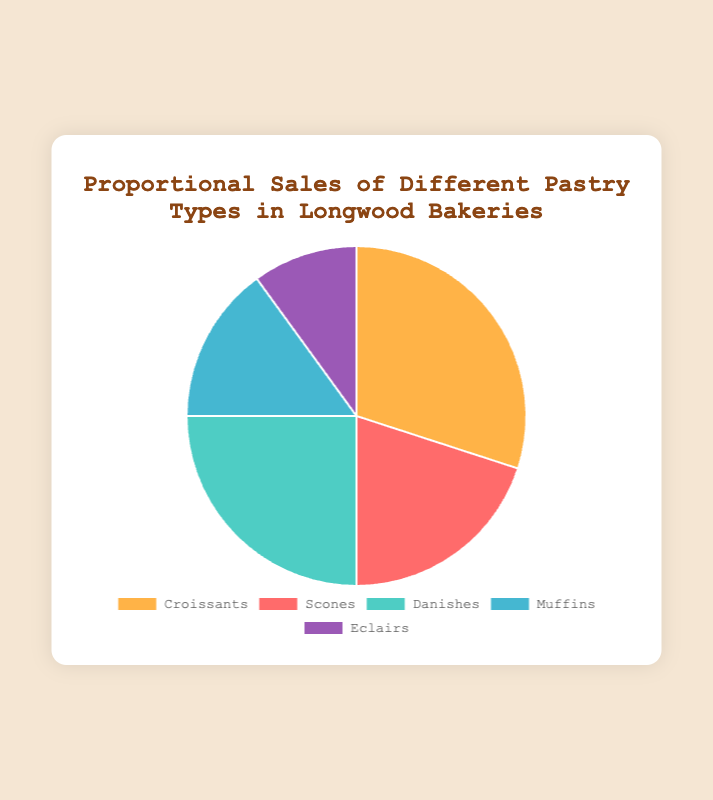What percentage of pastry sales do Croissants and Danish together represent? First, identify the percentages from the pie chart: Croissants (30%) and Danish (25%). Add these percentages together: 30% + 25% = 55%.
Answer: 55% Which pastry type has the lowest sales? Look for the smallest section of the pie chart. The smallest section is for Eclairs, representing 10% of sales.
Answer: Eclairs What is the difference in sales between Scones and Muffins? Identify the percentage of sales for Scones (20%) and Muffins (15%). Subtract the percentage of Muffins from Scones: 20% - 15% = 5%.
Answer: 5% Are the sales of Scones greater than the combined sales of Muffins and Eclairs? First, identify the sales percentages: Scones (20%), Muffins (15%), Eclairs (10%). Add the sales percentages for Muffins and Eclairs: 15% + 10% = 25%. Since 20% (Scones) is less than 25% (Muffins and Eclairs), the sales of Scones are not greater.
Answer: No Which color represents the Croissants in the pie chart? According to the background colors listed, the color for Croissants is given first. The first color in the list is light orange.
Answer: Light orange What is the combined percentage of sales for pastries with sales under 20%? Identify the pastries with sales under 20%: Muffins (15%) and Eclairs (10%). Add these percentages together: 15% + 10% = 25%.
Answer: 25% Which two pastry types together make up half of the total sales? Find a combination of two pastry types whose sales add up to approximately 50%. Croissants (30%) and Danish (25%) together make 55%, but Scones (20%) and Danish (25%) together exactly make 50%. 30% + 25% = 55%. Croissants and Danish make up more than half, so they are a better fit.
Answer: Croissants and Danish How many types of pastries have a sales percentage below 25%? Identify and count the pastries that have a percentage below 25%: Scones (20%), Muffins (15%), and Eclairs (10%). There are three pastries in total.
Answer: Three Which pastry has more sales: Muffins or Danish? Compare the sales percentages of Muffins (15%) and Danish (25%). Danish has a higher percentage.
Answer: Danish 